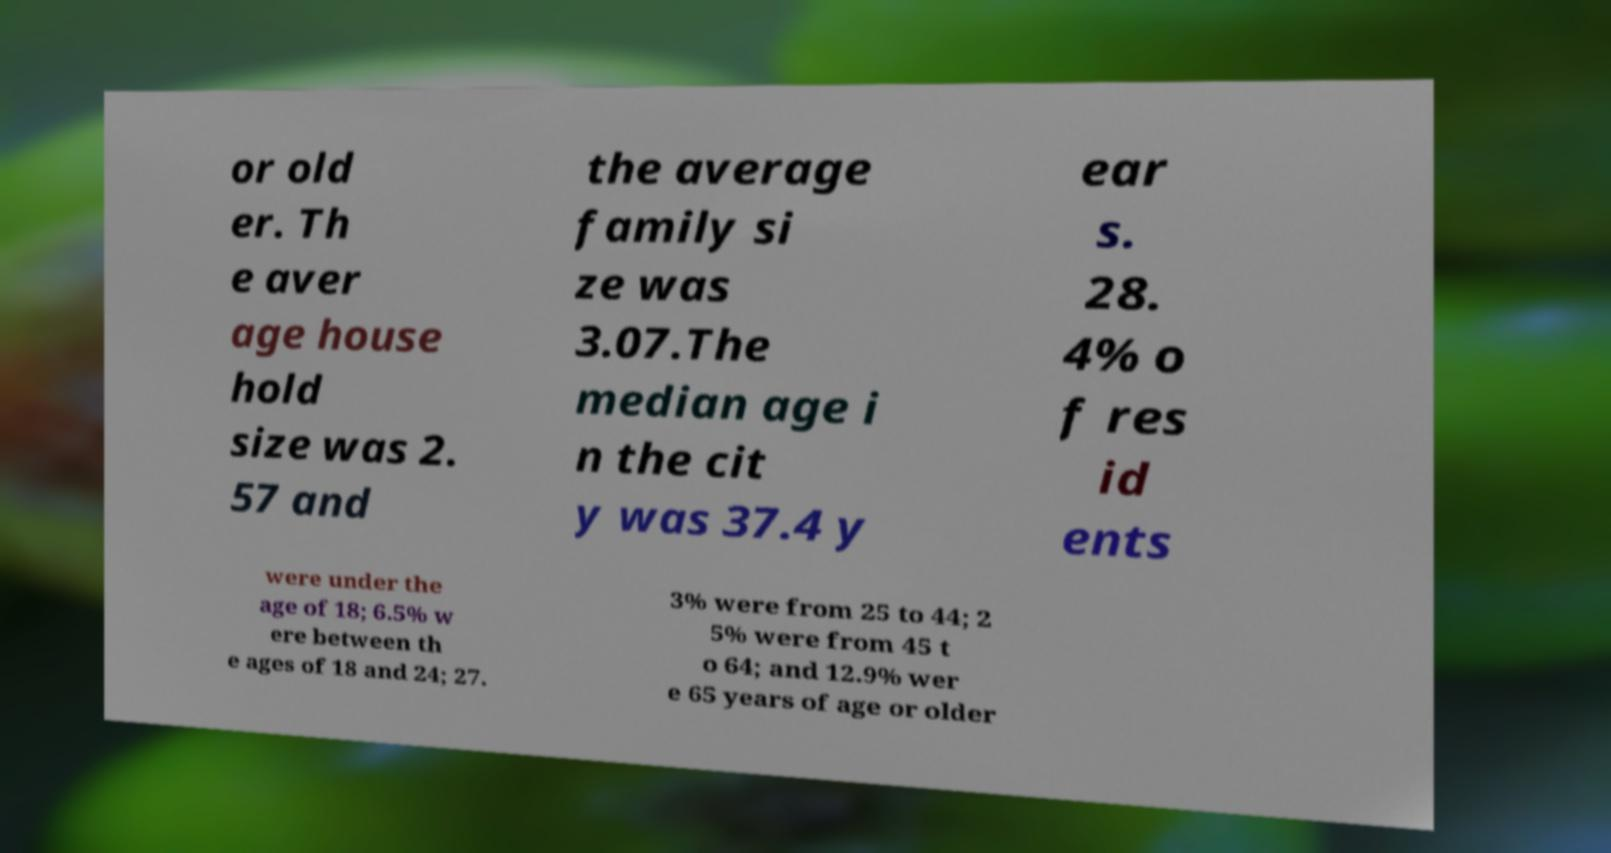For documentation purposes, I need the text within this image transcribed. Could you provide that? or old er. Th e aver age house hold size was 2. 57 and the average family si ze was 3.07.The median age i n the cit y was 37.4 y ear s. 28. 4% o f res id ents were under the age of 18; 6.5% w ere between th e ages of 18 and 24; 27. 3% were from 25 to 44; 2 5% were from 45 t o 64; and 12.9% wer e 65 years of age or older 